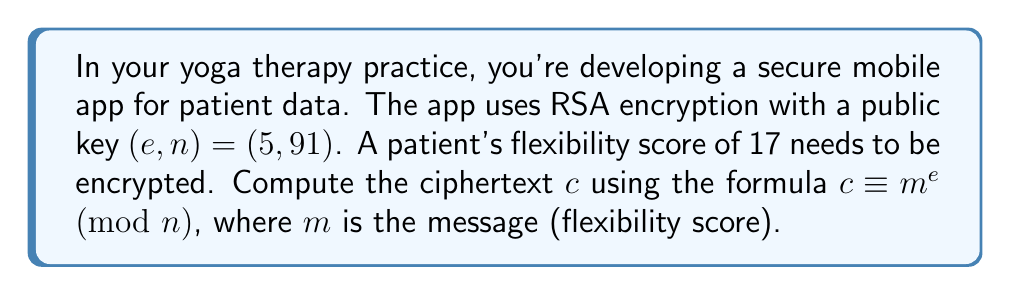Help me with this question. To compute the modular exponentiation for RSA encryption, we follow these steps:

1) We have:
   $m = 17$ (the message/flexibility score)
   $e = 5$ (the public exponent)
   $n = 91$ (the modulus)

2) We need to calculate $c \equiv 17^5 \pmod{91}$

3) Let's break this down using the square-and-multiply method:

   $17^1 \equiv 17 \pmod{91}$
   $17^2 \equiv 17 \cdot 17 \equiv 289 \equiv 16 \pmod{91}$
   $17^4 \equiv 16 \cdot 16 \equiv 256 \equiv 74 \pmod{91}$

4) Now, $17^5 = 17^4 \cdot 17^1$, so:

   $17^5 \equiv 74 \cdot 17 \pmod{91}$

5) Calculate $74 \cdot 17$:
   
   $74 \cdot 17 = 1258 \equiv 82 \pmod{91}$

Therefore, $c \equiv 17^5 \equiv 82 \pmod{91}$
Answer: $82$ 